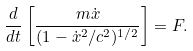Convert formula to latex. <formula><loc_0><loc_0><loc_500><loc_500>\frac { d } { d t } \left [ \frac { m \dot { x } } { ( 1 - \dot { x } ^ { 2 } / c ^ { 2 } ) ^ { 1 / 2 } } \right ] = F .</formula> 